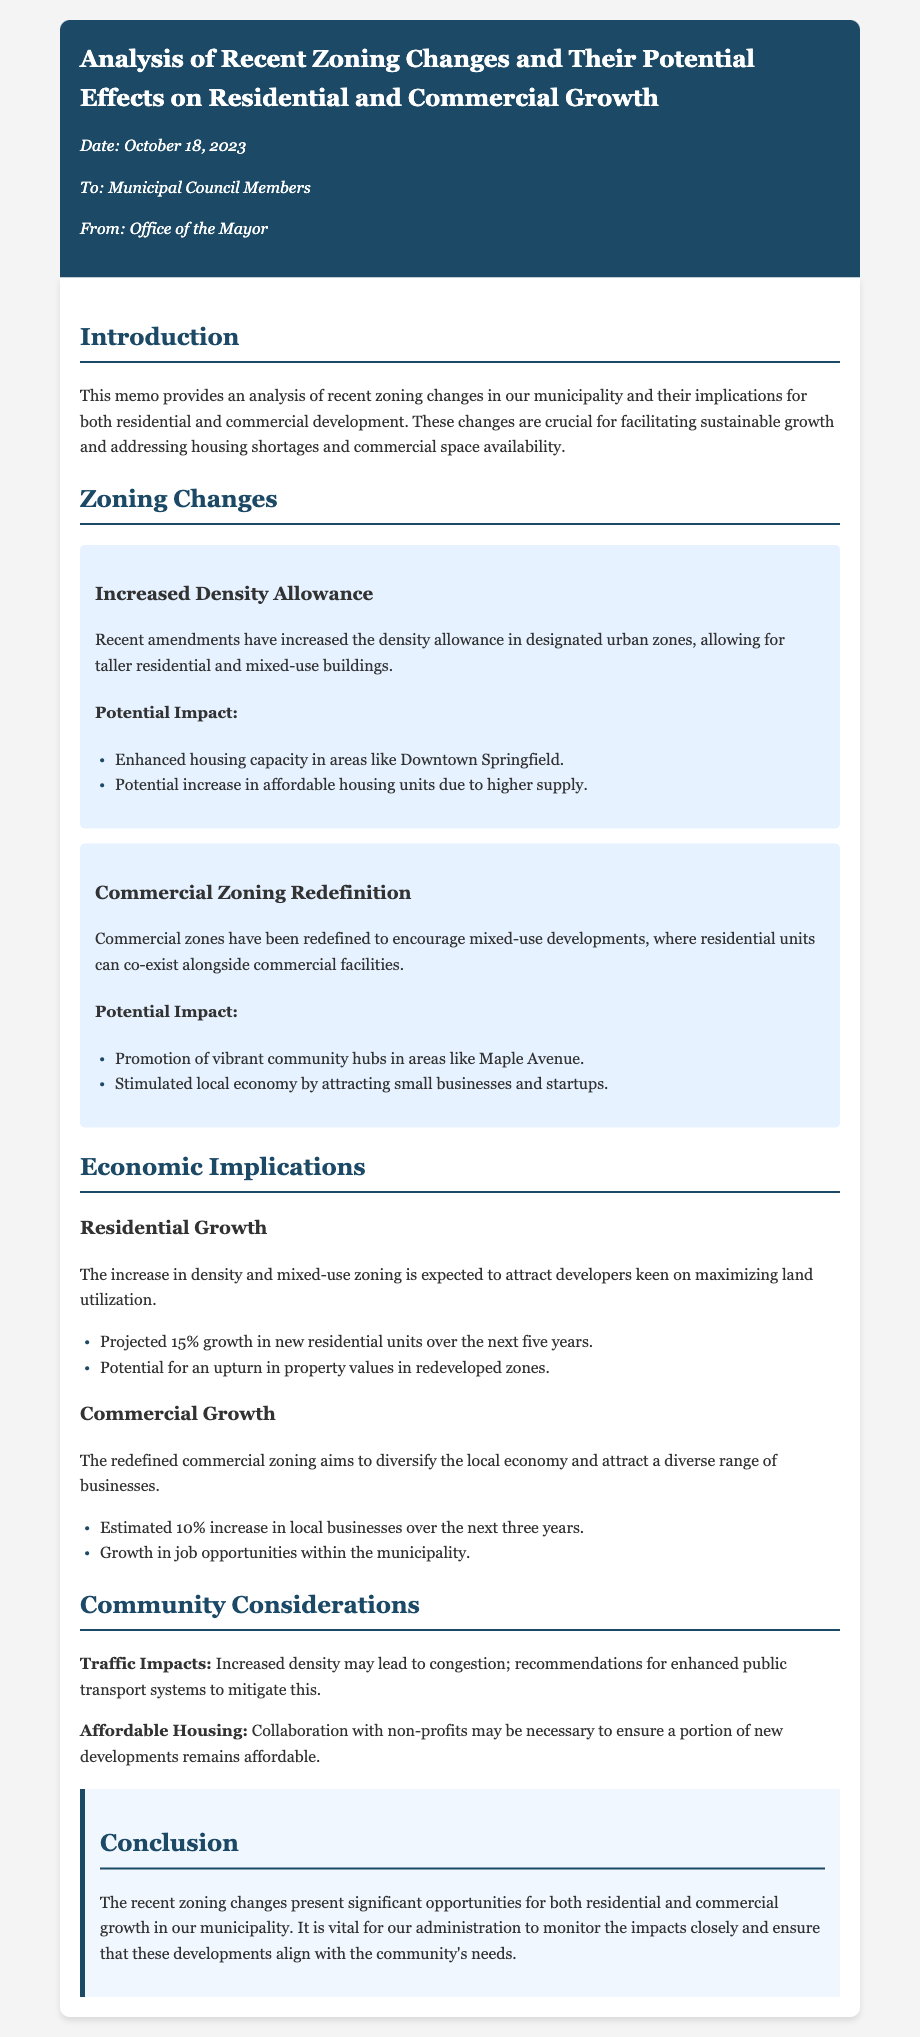What is the date of the memo? The memo was dated October 18, 2023.
Answer: October 18, 2023 What zoning change is mentioned in the document? The memo mentions increased density allowance as a zoning change.
Answer: Increased Density Allowance What is the projected growth percentage for new residential units? The document states that the projected growth in new residential units is 15% over the next five years.
Answer: 15% What area is expected to see enhanced housing capacity? The memo indicates that Downtown Springfield is expected to see enhanced housing capacity.
Answer: Downtown Springfield What type of developments do the commercial zoning changes encourage? The commercial zoning changes encourage mixed-use developments.
Answer: Mixed-use developments What is one recommendation to address traffic impacts? The document recommends enhanced public transport systems to mitigate traffic congestion.
Answer: Enhanced public transport systems What potential economic impact is expected from the redefined commercial zoning? The memo states an estimated 10% increase in local businesses is expected over the next three years.
Answer: 10% What is the conclusion of the memo regarding the zoning changes? The conclusion emphasizes significant opportunities for residential and commercial growth and the need for monitoring impacts.
Answer: Significant opportunities for growth What community consideration is highlighted regarding affordable housing? The document highlights collaboration with non-profits as necessary for affordable housing.
Answer: Collaboration with non-profits 